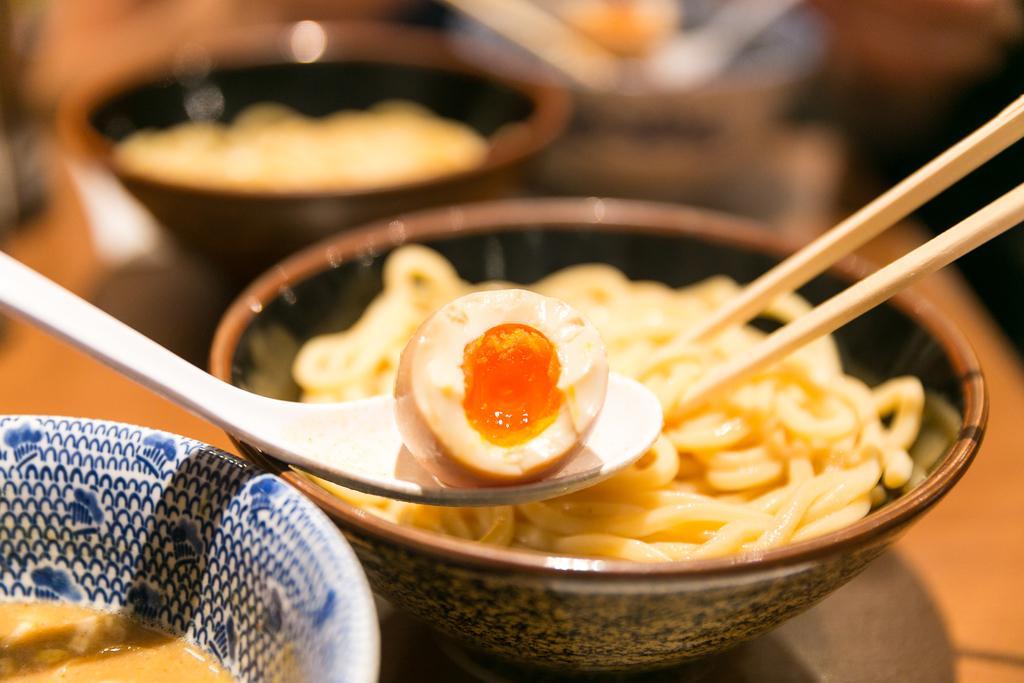Can you describe this image briefly? In this image, there is a table on that table there is a bowl which is in brown color, it contains some food item, there is a spoon which is in white color, there is a egg in the spoon, in the left side there is a white color bowl which contains some food item. 